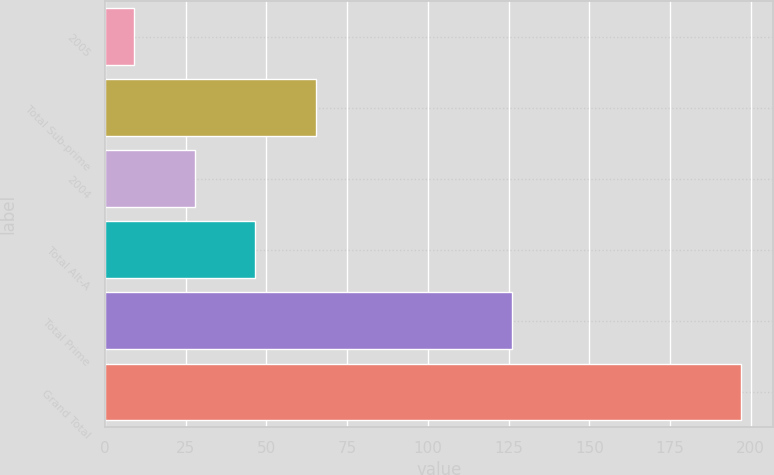Convert chart. <chart><loc_0><loc_0><loc_500><loc_500><bar_chart><fcel>2005<fcel>Total Sub-prime<fcel>2004<fcel>Total Alt-A<fcel>Total Prime<fcel>Grand Total<nl><fcel>9<fcel>65.4<fcel>27.8<fcel>46.6<fcel>126<fcel>197<nl></chart> 